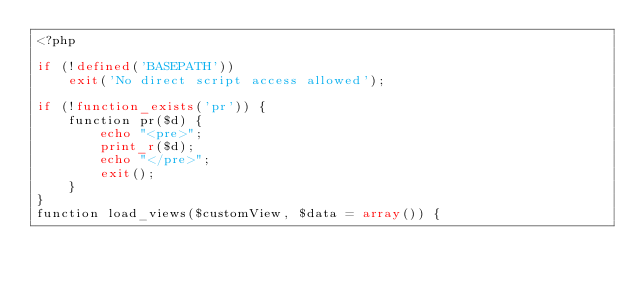Convert code to text. <code><loc_0><loc_0><loc_500><loc_500><_PHP_><?php

if (!defined('BASEPATH'))
    exit('No direct script access allowed');

if (!function_exists('pr')) {
    function pr($d) {
        echo "<pre>";
        print_r($d);
        echo "</pre>";
        exit();
    }
}
function load_views($customView, $data = array()) {</code> 